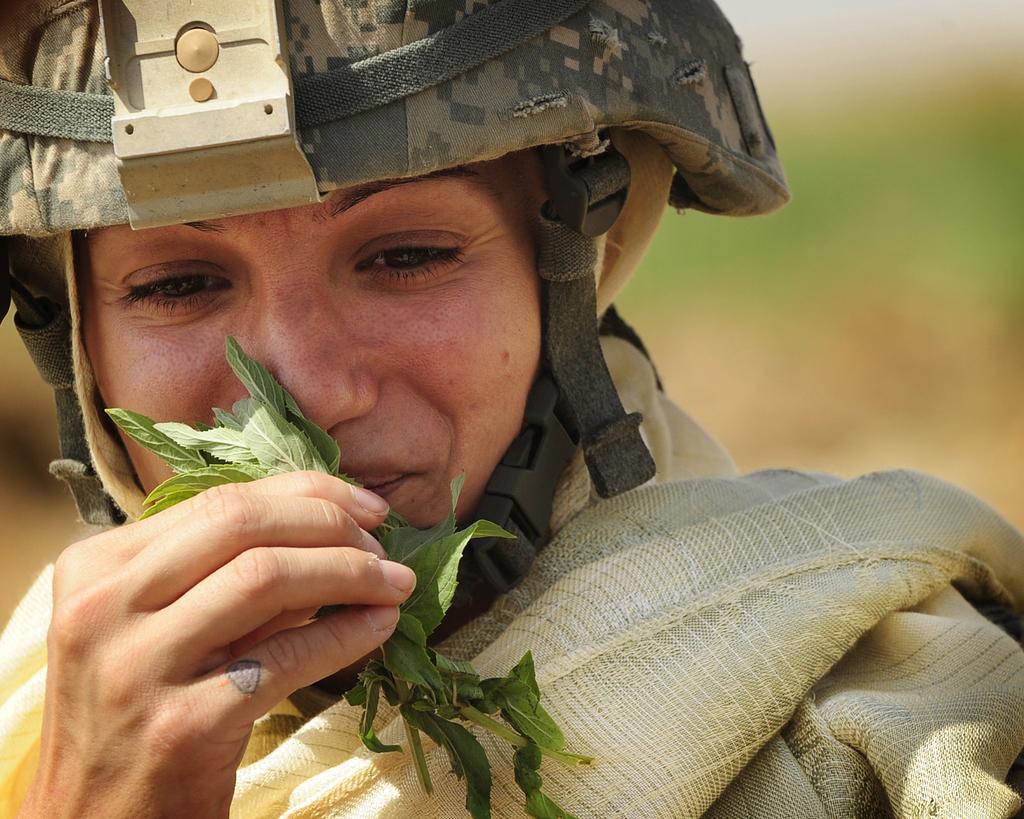Describe this image in one or two sentences. In this image I can see a woman, I can see she is holding green colour leaves and I can see she is wearing a helmet. I can also see this image is blurry from background. 